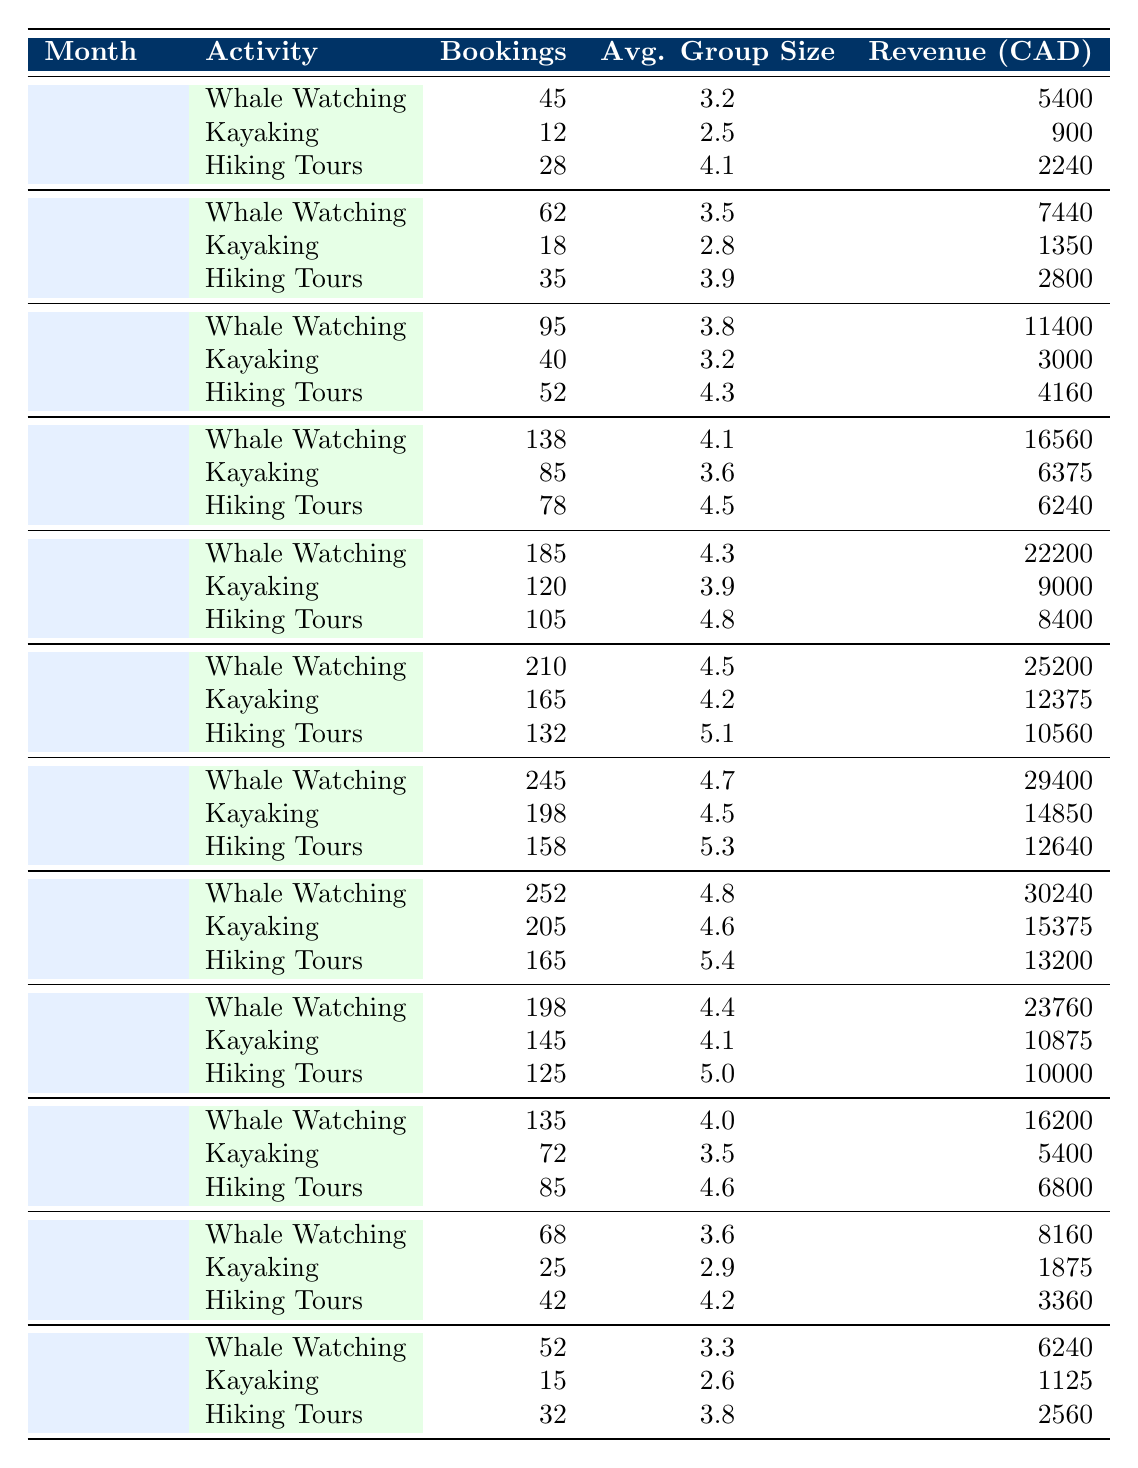What is the total number of bookings for Whale Watching in July? The table shows that there were 245 bookings for Whale Watching in July.
Answer: 245 What is the average group size for Kayaking in the month of April? In April, the average group size for Kayaking is stated as 3.6 in the table.
Answer: 3.6 Which outdoor activity generated the highest revenue in June? From the table, Whale Watching generated the highest revenue in June with 25200 CAD.
Answer: Whale Watching How many more bookings were there for Hiking Tours in May compared to December? For May, there were 105 bookings for Hiking Tours, and for December, there were 32 bookings. The difference is 105 - 32 = 73.
Answer: 73 What is the total revenue from Kayaking across all months? The total revenue from Kayaking can be calculated by adding all the revenues from each month: 900 + 1350 + 3000 + 6375 + 9000 + 12375 + 14850 + 15375 + 10875 + 5400 + 1875 + 1125 = 78250 CAD.
Answer: 78250 Is there an increase in bookings for Hiking Tours from March to April? Yes, in March there were 52 bookings, and in April there were 78 bookings, indicating an increase of 78 - 52 = 26 bookings.
Answer: Yes What was the total number of bookings for all activities in August? In August, the bookings are as follows: Whale Watching 252, Kayaking 205, Hiking Tours 165. The total bookings for August is 252 + 205 + 165 = 622.
Answer: 622 What is the percentage of Whale Watching bookings out of total activity bookings in September? In September, the total bookings are 198 (Whale Watching) + 145 (Kayaking) + 125 (Hiking Tours) = 468. The percentage for Whale Watching is (198 / 468) * 100 ≈ 42.3%.
Answer: 42.3% How does the average group size for Hiking Tours in May compare to that in November? The average group size for Hiking Tours in May is 4.8, while in November it is 4.2. The comparison shows May's group size is larger by 4.8 - 4.2 = 0.6.
Answer: Larger by 0.6 In which month did Kayaking have the lowest number of bookings and what was that number? Kayaking had the lowest bookings in January with 12 bookings.
Answer: 12 